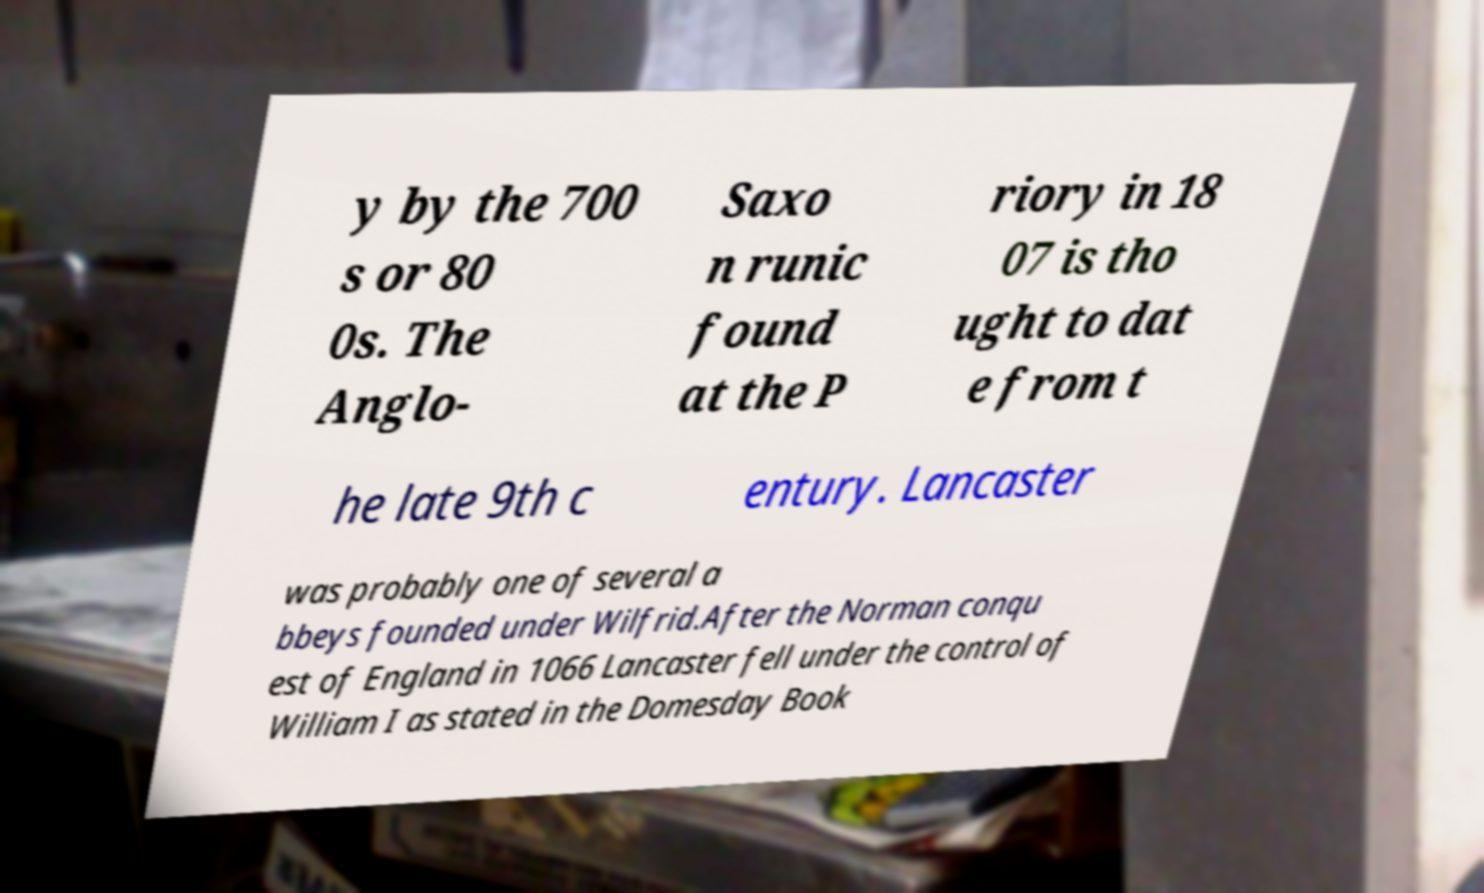Could you extract and type out the text from this image? y by the 700 s or 80 0s. The Anglo- Saxo n runic found at the P riory in 18 07 is tho ught to dat e from t he late 9th c entury. Lancaster was probably one of several a bbeys founded under Wilfrid.After the Norman conqu est of England in 1066 Lancaster fell under the control of William I as stated in the Domesday Book 